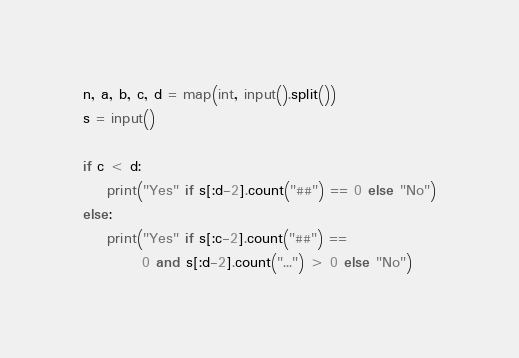<code> <loc_0><loc_0><loc_500><loc_500><_Python_>n, a, b, c, d = map(int, input().split())
s = input()

if c < d:
    print("Yes" if s[:d-2].count("##") == 0 else "No")
else:
    print("Yes" if s[:c-2].count("##") ==
          0 and s[:d-2].count("...") > 0 else "No")</code> 